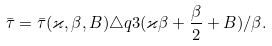<formula> <loc_0><loc_0><loc_500><loc_500>\bar { \tau } = \bar { \tau } ( \varkappa , \beta , B ) \triangle q 3 ( \varkappa \beta + \frac { \beta } { 2 } + B ) / \beta .</formula> 